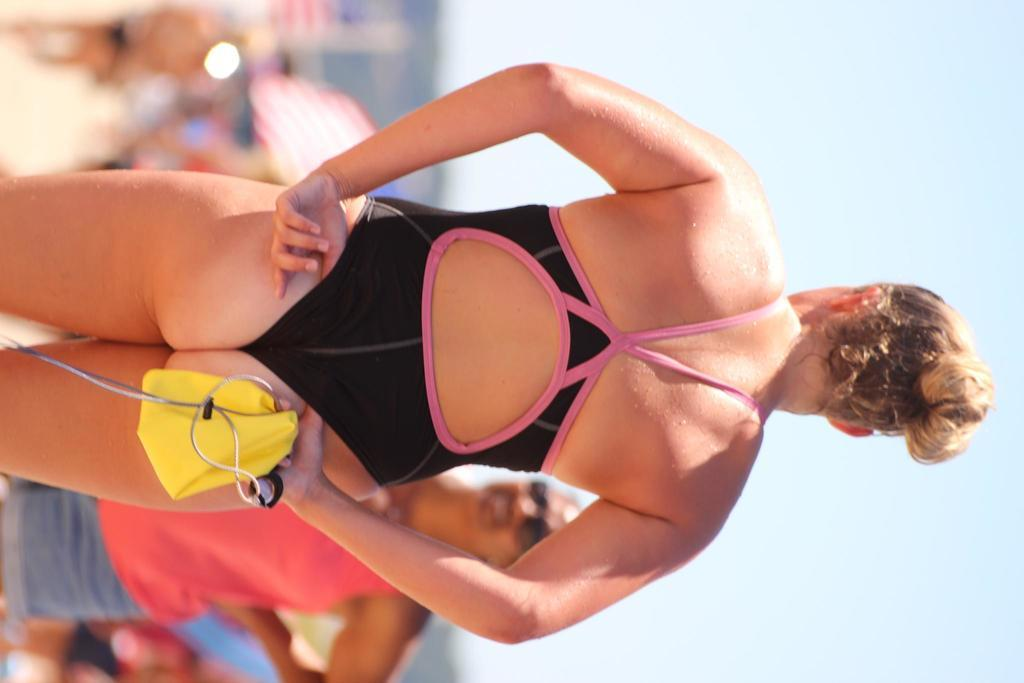What is the main subject of the image? There is a person holding objects in the center of the image. Can you describe the surrounding environment in the image? There are other people in the background of the image, and the sky is visible at the top. What type of animal can be seen interacting with the person holding objects in the image? There is no animal present in the image; it only features a person holding objects and other people in the background. 